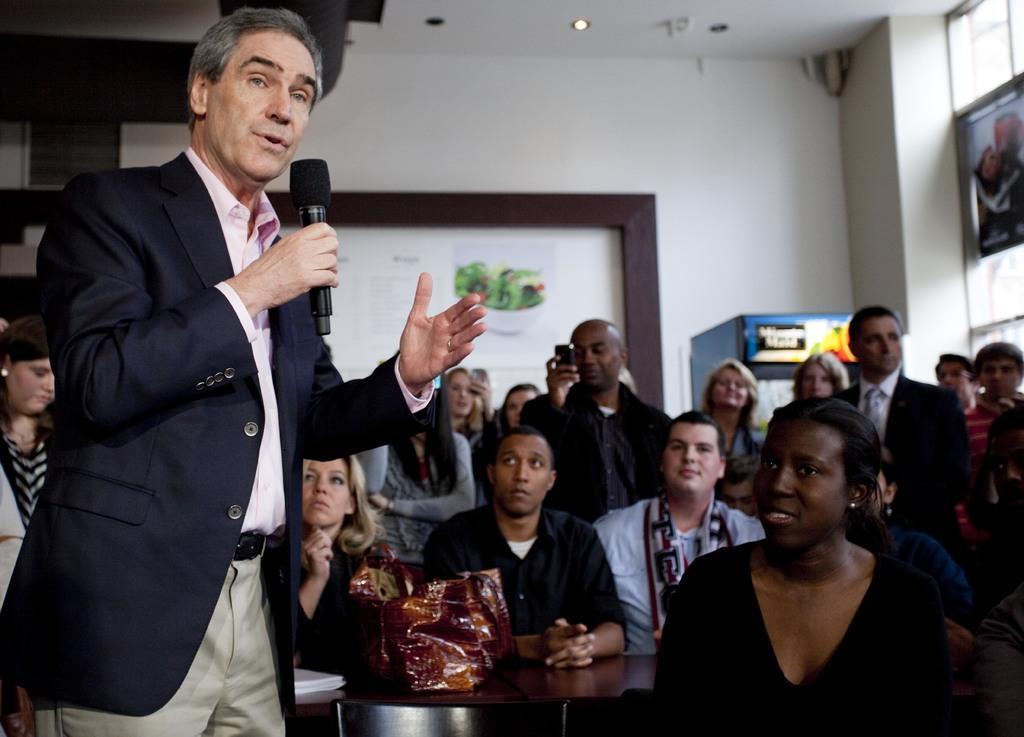In one or two sentences, can you explain what this image depicts? In this image we can see a man wearing the suit and holding the mike and standing. In the background we can see the people sitting. We can also see a few people standing. There is also a table and we can see the bags on the table. In the background we can see the board, wall, window, poster and also the ceiling with the ceiling lights. We can also see the minute maid machine. 